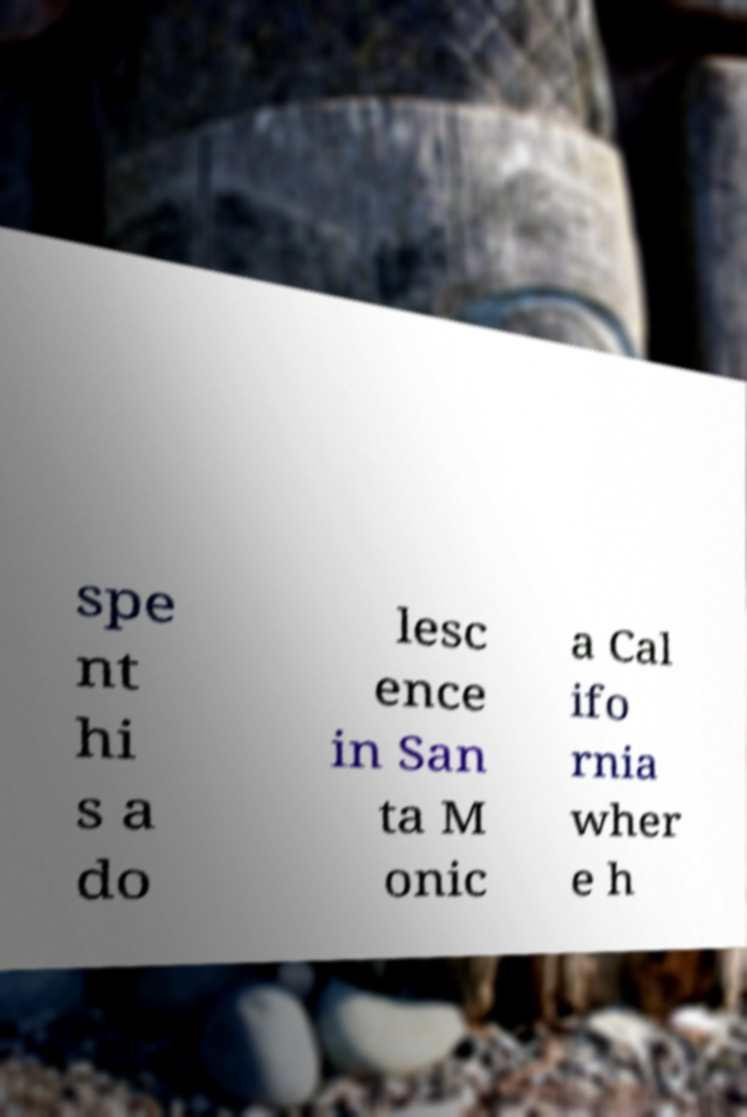Can you accurately transcribe the text from the provided image for me? spe nt hi s a do lesc ence in San ta M onic a Cal ifo rnia wher e h 